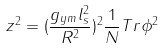<formula> <loc_0><loc_0><loc_500><loc_500>z ^ { 2 } = ( \frac { g _ { y m } l _ { s } ^ { 2 } } { R ^ { 2 } } ) ^ { 2 } \frac { 1 } { N } T r \phi ^ { 2 }</formula> 